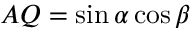<formula> <loc_0><loc_0><loc_500><loc_500>A Q = \sin \alpha \cos \beta</formula> 